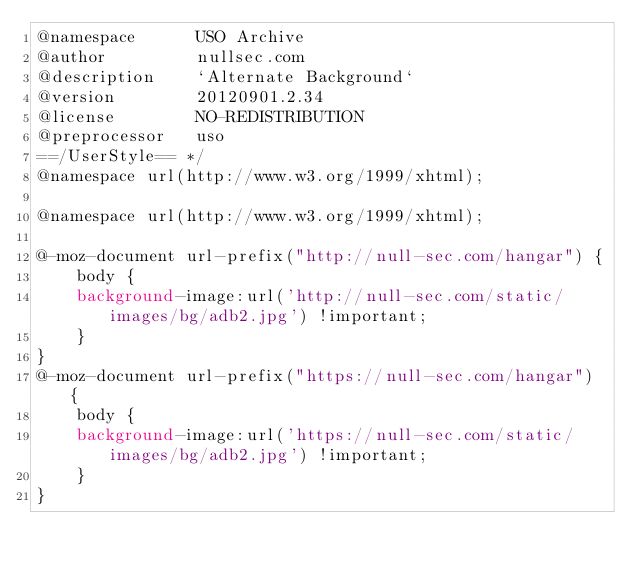<code> <loc_0><loc_0><loc_500><loc_500><_CSS_>@namespace      USO Archive
@author         nullsec.com
@description    `Alternate Background`
@version        20120901.2.34
@license        NO-REDISTRIBUTION
@preprocessor   uso
==/UserStyle== */
@namespace url(http://www.w3.org/1999/xhtml);

@namespace url(http://www.w3.org/1999/xhtml);

@-moz-document url-prefix("http://null-sec.com/hangar") {
    body {
    background-image:url('http://null-sec.com/static/images/bg/adb2.jpg') !important;
    }
}
@-moz-document url-prefix("https://null-sec.com/hangar") {
    body {
    background-image:url('https://null-sec.com/static/images/bg/adb2.jpg') !important;
    }
}</code> 